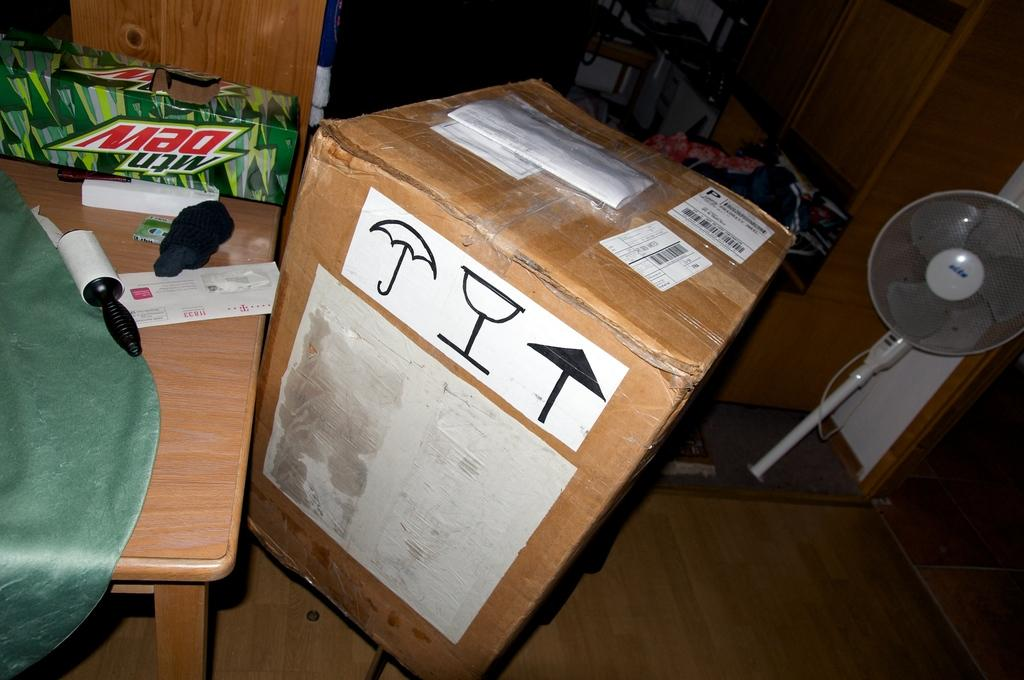What piece of furniture is present in the image? There is a table in the image. What is placed on the table? There is a box and a table fan on the table. Can you describe any other objects on the table? No, the facts only mention a box and a table fan on the table. What type of objects can be seen in the background of the image? There are wooden objects in the background of the image. Can you tell me the relation between the butter and the lake in the image? There is no butter or lake present in the image, so it is not possible to determine any relation between them. 